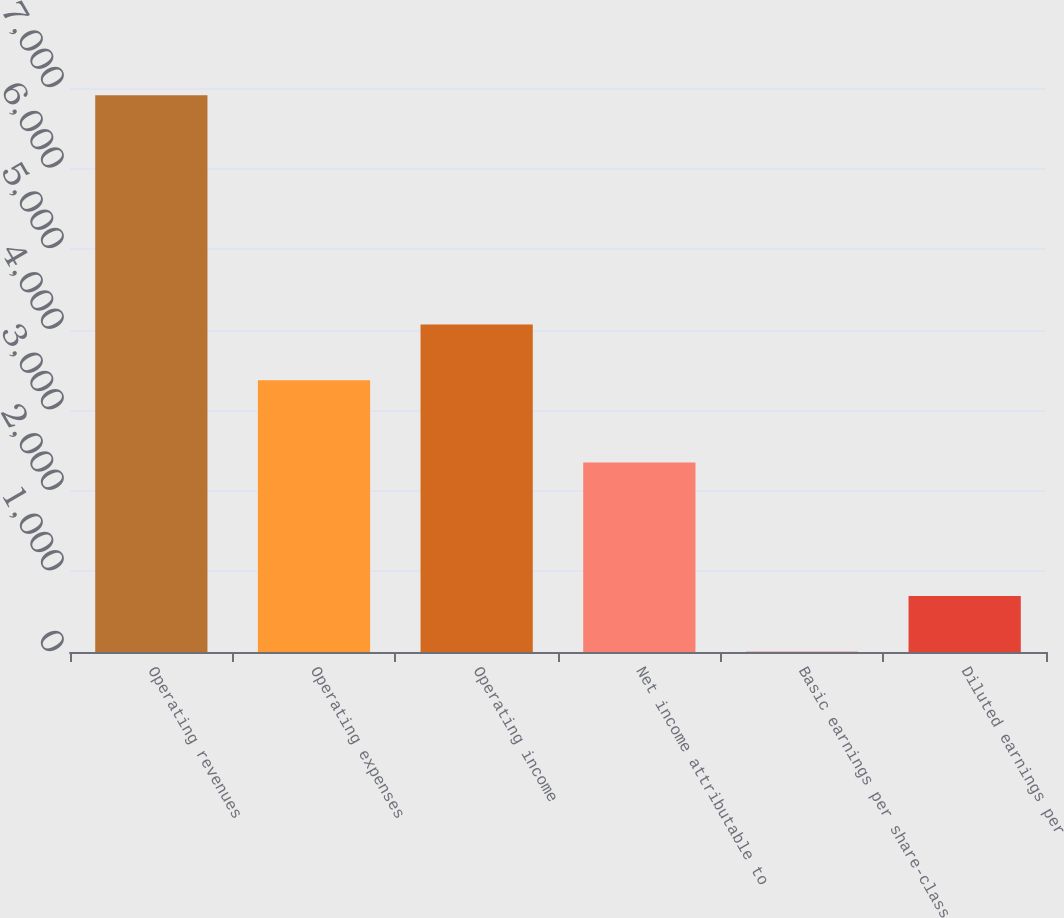<chart> <loc_0><loc_0><loc_500><loc_500><bar_chart><fcel>Operating revenues<fcel>Operating expenses<fcel>Operating income<fcel>Net income attributable to<fcel>Basic earnings per share-class<fcel>Diluted earnings per<nl><fcel>6911<fcel>3373<fcel>4063.79<fcel>2353<fcel>3.1<fcel>693.89<nl></chart> 